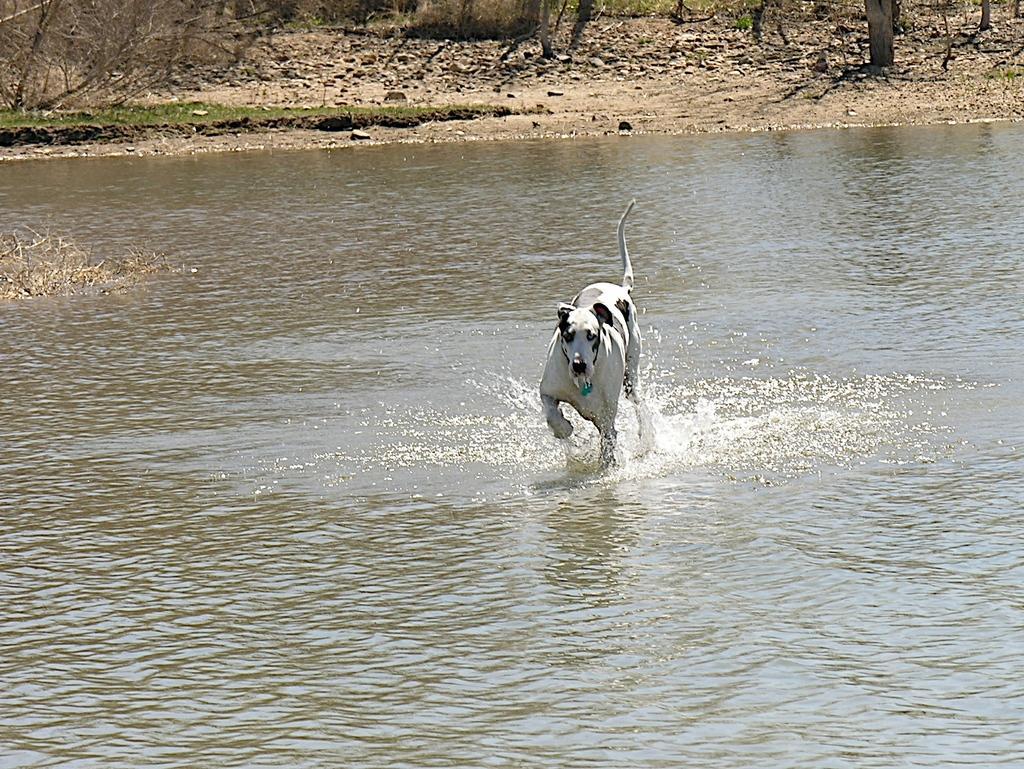How would you summarize this image in a sentence or two? In the center of the image, we can see a dog on the water and in the background, there are trees. 